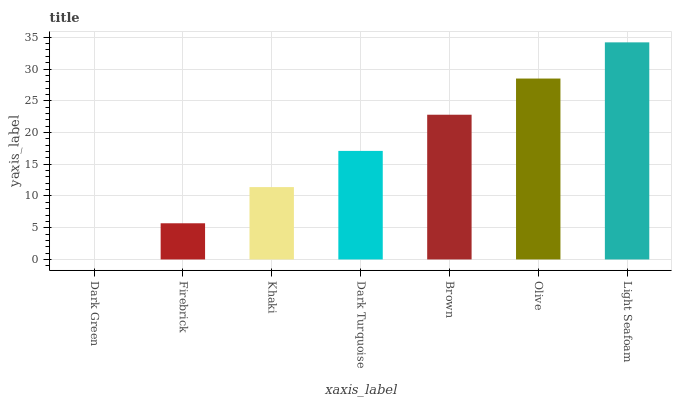Is Firebrick the minimum?
Answer yes or no. No. Is Firebrick the maximum?
Answer yes or no. No. Is Firebrick greater than Dark Green?
Answer yes or no. Yes. Is Dark Green less than Firebrick?
Answer yes or no. Yes. Is Dark Green greater than Firebrick?
Answer yes or no. No. Is Firebrick less than Dark Green?
Answer yes or no. No. Is Dark Turquoise the high median?
Answer yes or no. Yes. Is Dark Turquoise the low median?
Answer yes or no. Yes. Is Brown the high median?
Answer yes or no. No. Is Firebrick the low median?
Answer yes or no. No. 